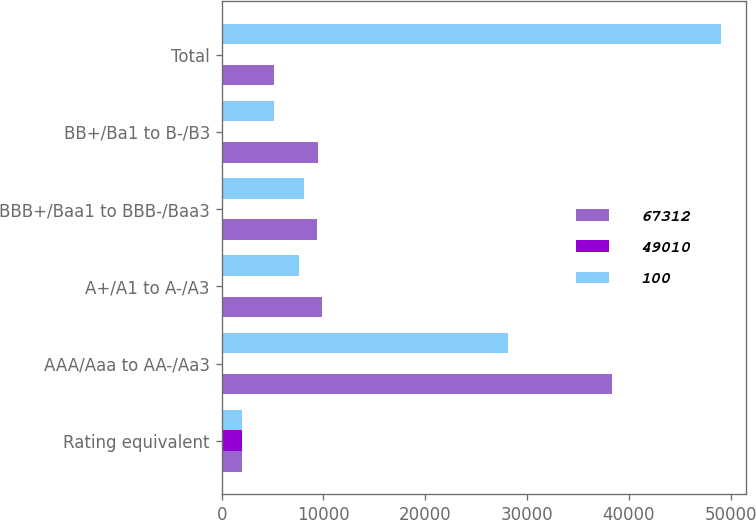Convert chart to OTSL. <chart><loc_0><loc_0><loc_500><loc_500><stacked_bar_chart><ecel><fcel>Rating equivalent<fcel>AAA/Aaa to AA-/Aa3<fcel>A+/A1 to A-/A3<fcel>BBB+/Baa1 to BBB-/Baa3<fcel>BB+/Ba1 to B-/B3<fcel>Total<nl><fcel>67312<fcel>2007<fcel>38314<fcel>9855<fcel>9335<fcel>9451<fcel>5150<nl><fcel>49010<fcel>2007<fcel>57<fcel>15<fcel>14<fcel>14<fcel>100<nl><fcel>100<fcel>2006<fcel>28150<fcel>7588<fcel>8044<fcel>5150<fcel>49010<nl></chart> 